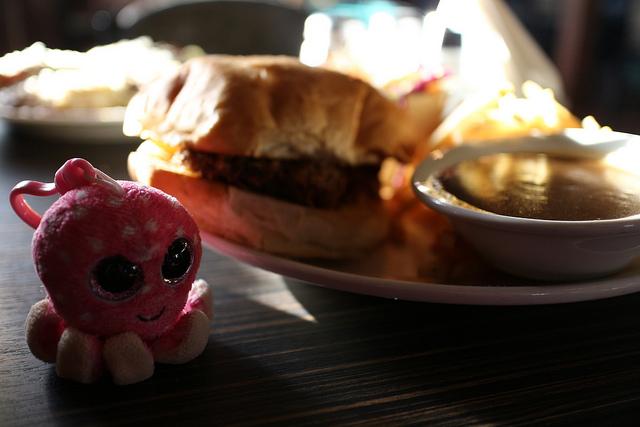Is there a hamburger on the plate?
Concise answer only. Yes. Is it daytime?
Give a very brief answer. Yes. What type of animal does the toy depict?
Answer briefly. Octopus. 